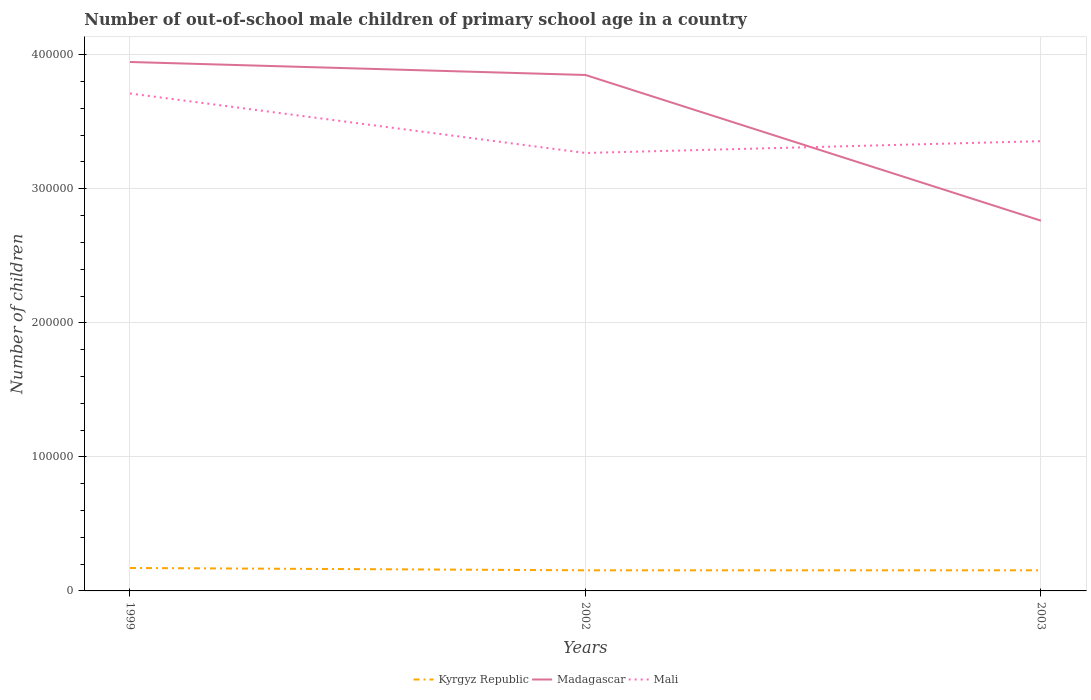How many different coloured lines are there?
Your response must be concise. 3. Across all years, what is the maximum number of out-of-school male children in Madagascar?
Give a very brief answer. 2.76e+05. What is the difference between the highest and the second highest number of out-of-school male children in Mali?
Provide a succinct answer. 4.44e+04. Is the number of out-of-school male children in Kyrgyz Republic strictly greater than the number of out-of-school male children in Mali over the years?
Provide a short and direct response. Yes. How many lines are there?
Keep it short and to the point. 3. Are the values on the major ticks of Y-axis written in scientific E-notation?
Offer a very short reply. No. Does the graph contain any zero values?
Offer a very short reply. No. Where does the legend appear in the graph?
Keep it short and to the point. Bottom center. How many legend labels are there?
Your response must be concise. 3. How are the legend labels stacked?
Provide a succinct answer. Horizontal. What is the title of the graph?
Your answer should be compact. Number of out-of-school male children of primary school age in a country. Does "Hungary" appear as one of the legend labels in the graph?
Give a very brief answer. No. What is the label or title of the Y-axis?
Offer a very short reply. Number of children. What is the Number of children of Kyrgyz Republic in 1999?
Give a very brief answer. 1.71e+04. What is the Number of children of Madagascar in 1999?
Offer a terse response. 3.95e+05. What is the Number of children of Mali in 1999?
Your answer should be compact. 3.71e+05. What is the Number of children of Kyrgyz Republic in 2002?
Your answer should be very brief. 1.54e+04. What is the Number of children in Madagascar in 2002?
Your answer should be compact. 3.85e+05. What is the Number of children in Mali in 2002?
Provide a short and direct response. 3.27e+05. What is the Number of children in Kyrgyz Republic in 2003?
Your answer should be very brief. 1.54e+04. What is the Number of children of Madagascar in 2003?
Offer a very short reply. 2.76e+05. What is the Number of children in Mali in 2003?
Offer a terse response. 3.36e+05. Across all years, what is the maximum Number of children of Kyrgyz Republic?
Keep it short and to the point. 1.71e+04. Across all years, what is the maximum Number of children in Madagascar?
Keep it short and to the point. 3.95e+05. Across all years, what is the maximum Number of children in Mali?
Offer a very short reply. 3.71e+05. Across all years, what is the minimum Number of children of Kyrgyz Republic?
Keep it short and to the point. 1.54e+04. Across all years, what is the minimum Number of children of Madagascar?
Give a very brief answer. 2.76e+05. Across all years, what is the minimum Number of children of Mali?
Keep it short and to the point. 3.27e+05. What is the total Number of children of Kyrgyz Republic in the graph?
Your response must be concise. 4.79e+04. What is the total Number of children in Madagascar in the graph?
Provide a short and direct response. 1.06e+06. What is the total Number of children in Mali in the graph?
Give a very brief answer. 1.03e+06. What is the difference between the Number of children in Kyrgyz Republic in 1999 and that in 2002?
Your answer should be very brief. 1732. What is the difference between the Number of children in Madagascar in 1999 and that in 2002?
Your answer should be very brief. 9696. What is the difference between the Number of children of Mali in 1999 and that in 2002?
Ensure brevity in your answer.  4.44e+04. What is the difference between the Number of children of Kyrgyz Republic in 1999 and that in 2003?
Your answer should be very brief. 1723. What is the difference between the Number of children of Madagascar in 1999 and that in 2003?
Your response must be concise. 1.18e+05. What is the difference between the Number of children in Mali in 1999 and that in 2003?
Provide a succinct answer. 3.56e+04. What is the difference between the Number of children in Kyrgyz Republic in 2002 and that in 2003?
Your answer should be very brief. -9. What is the difference between the Number of children of Madagascar in 2002 and that in 2003?
Your answer should be compact. 1.09e+05. What is the difference between the Number of children of Mali in 2002 and that in 2003?
Offer a very short reply. -8819. What is the difference between the Number of children in Kyrgyz Republic in 1999 and the Number of children in Madagascar in 2002?
Keep it short and to the point. -3.68e+05. What is the difference between the Number of children of Kyrgyz Republic in 1999 and the Number of children of Mali in 2002?
Provide a succinct answer. -3.10e+05. What is the difference between the Number of children in Madagascar in 1999 and the Number of children in Mali in 2002?
Your answer should be compact. 6.79e+04. What is the difference between the Number of children in Kyrgyz Republic in 1999 and the Number of children in Madagascar in 2003?
Provide a short and direct response. -2.59e+05. What is the difference between the Number of children in Kyrgyz Republic in 1999 and the Number of children in Mali in 2003?
Provide a short and direct response. -3.18e+05. What is the difference between the Number of children in Madagascar in 1999 and the Number of children in Mali in 2003?
Provide a short and direct response. 5.91e+04. What is the difference between the Number of children of Kyrgyz Republic in 2002 and the Number of children of Madagascar in 2003?
Keep it short and to the point. -2.61e+05. What is the difference between the Number of children of Kyrgyz Republic in 2002 and the Number of children of Mali in 2003?
Your answer should be very brief. -3.20e+05. What is the difference between the Number of children of Madagascar in 2002 and the Number of children of Mali in 2003?
Make the answer very short. 4.94e+04. What is the average Number of children in Kyrgyz Republic per year?
Your answer should be compact. 1.60e+04. What is the average Number of children of Madagascar per year?
Make the answer very short. 3.52e+05. What is the average Number of children in Mali per year?
Your response must be concise. 3.44e+05. In the year 1999, what is the difference between the Number of children of Kyrgyz Republic and Number of children of Madagascar?
Your answer should be very brief. -3.77e+05. In the year 1999, what is the difference between the Number of children of Kyrgyz Republic and Number of children of Mali?
Provide a short and direct response. -3.54e+05. In the year 1999, what is the difference between the Number of children of Madagascar and Number of children of Mali?
Ensure brevity in your answer.  2.35e+04. In the year 2002, what is the difference between the Number of children in Kyrgyz Republic and Number of children in Madagascar?
Your answer should be compact. -3.70e+05. In the year 2002, what is the difference between the Number of children of Kyrgyz Republic and Number of children of Mali?
Keep it short and to the point. -3.11e+05. In the year 2002, what is the difference between the Number of children in Madagascar and Number of children in Mali?
Your answer should be very brief. 5.82e+04. In the year 2003, what is the difference between the Number of children in Kyrgyz Republic and Number of children in Madagascar?
Provide a succinct answer. -2.61e+05. In the year 2003, what is the difference between the Number of children of Kyrgyz Republic and Number of children of Mali?
Give a very brief answer. -3.20e+05. In the year 2003, what is the difference between the Number of children of Madagascar and Number of children of Mali?
Provide a short and direct response. -5.93e+04. What is the ratio of the Number of children in Kyrgyz Republic in 1999 to that in 2002?
Your answer should be very brief. 1.11. What is the ratio of the Number of children of Madagascar in 1999 to that in 2002?
Offer a very short reply. 1.03. What is the ratio of the Number of children in Mali in 1999 to that in 2002?
Offer a terse response. 1.14. What is the ratio of the Number of children in Kyrgyz Republic in 1999 to that in 2003?
Make the answer very short. 1.11. What is the ratio of the Number of children in Madagascar in 1999 to that in 2003?
Your answer should be compact. 1.43. What is the ratio of the Number of children in Mali in 1999 to that in 2003?
Your answer should be compact. 1.11. What is the ratio of the Number of children in Kyrgyz Republic in 2002 to that in 2003?
Ensure brevity in your answer.  1. What is the ratio of the Number of children in Madagascar in 2002 to that in 2003?
Provide a succinct answer. 1.39. What is the ratio of the Number of children of Mali in 2002 to that in 2003?
Your answer should be very brief. 0.97. What is the difference between the highest and the second highest Number of children in Kyrgyz Republic?
Offer a terse response. 1723. What is the difference between the highest and the second highest Number of children in Madagascar?
Offer a very short reply. 9696. What is the difference between the highest and the second highest Number of children in Mali?
Your answer should be very brief. 3.56e+04. What is the difference between the highest and the lowest Number of children of Kyrgyz Republic?
Provide a succinct answer. 1732. What is the difference between the highest and the lowest Number of children in Madagascar?
Provide a succinct answer. 1.18e+05. What is the difference between the highest and the lowest Number of children in Mali?
Your response must be concise. 4.44e+04. 